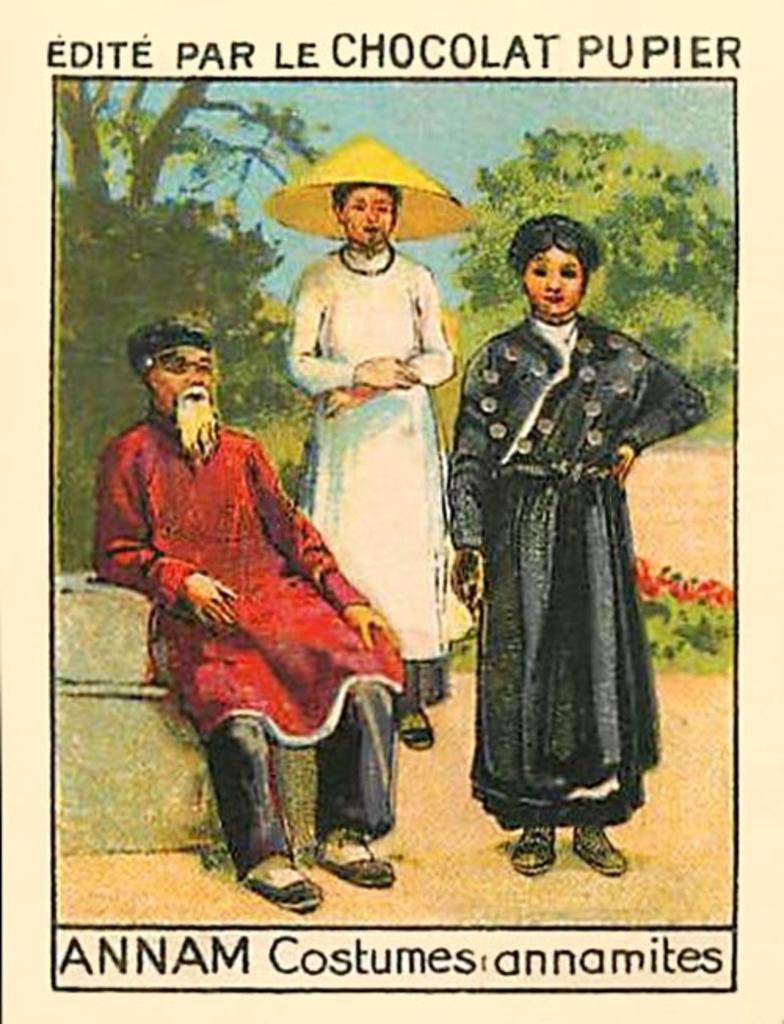Could you give a brief overview of what you see in this image? This is a picture where we can see a man is sitting on a platform and two persons are standing on the ground. In the background we can see trees, plants with flowers and sky. At the top and bottom we can see texts written on the image. 